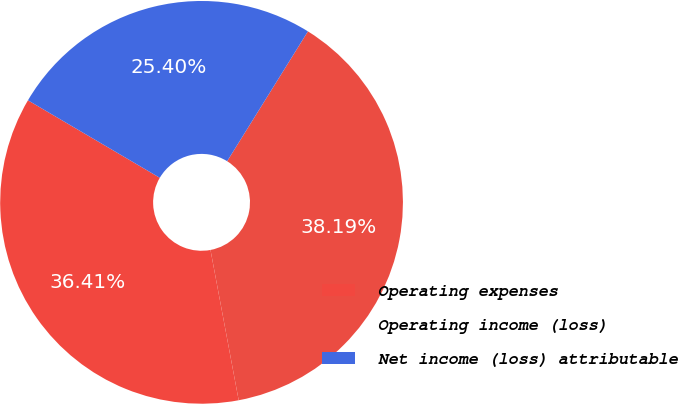Convert chart. <chart><loc_0><loc_0><loc_500><loc_500><pie_chart><fcel>Operating expenses<fcel>Operating income (loss)<fcel>Net income (loss) attributable<nl><fcel>36.41%<fcel>38.19%<fcel>25.4%<nl></chart> 